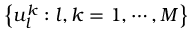<formula> <loc_0><loc_0><loc_500><loc_500>\left \{ u _ { l } ^ { k } \colon l , k = 1 , \cdots , M \right \}</formula> 